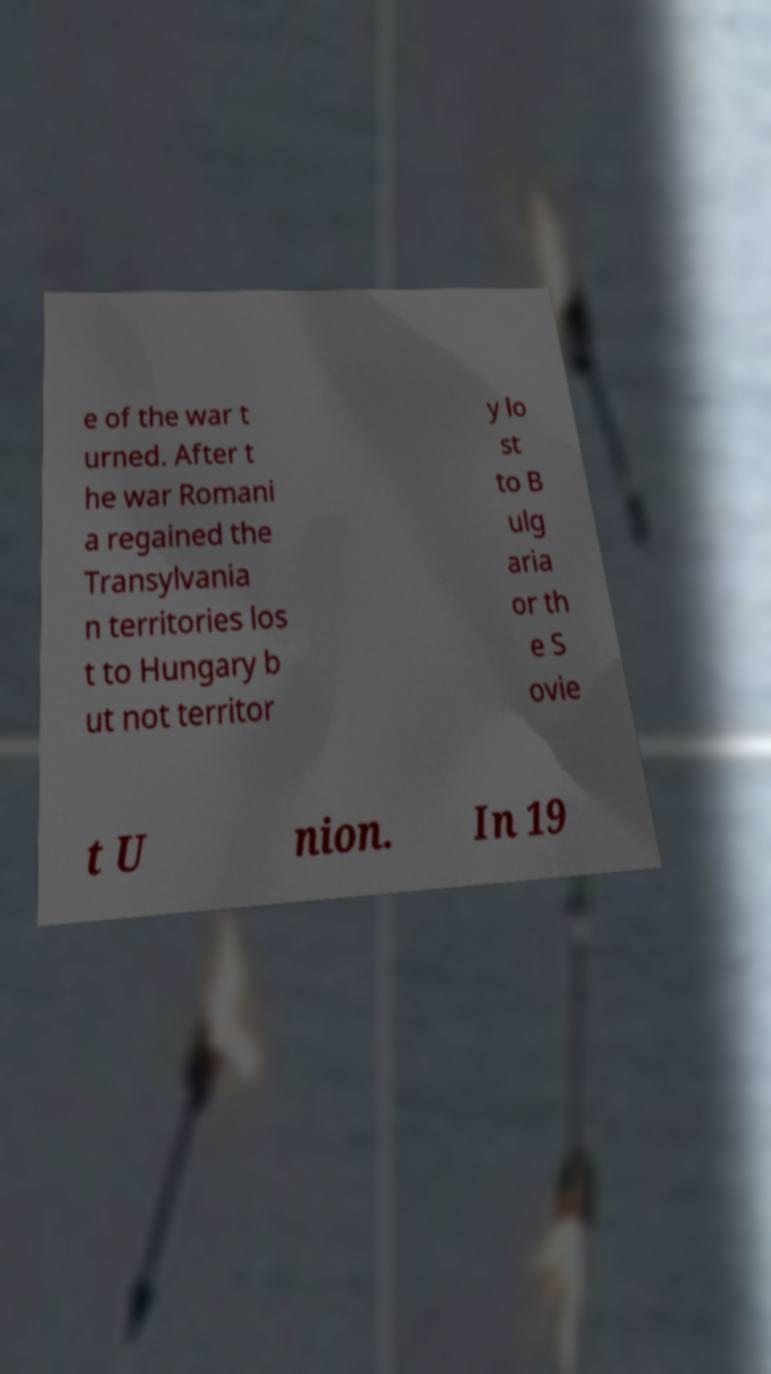Please identify and transcribe the text found in this image. e of the war t urned. After t he war Romani a regained the Transylvania n territories los t to Hungary b ut not territor y lo st to B ulg aria or th e S ovie t U nion. In 19 